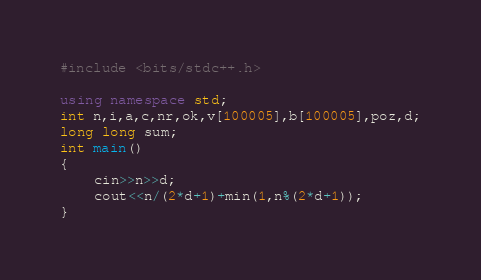Convert code to text. <code><loc_0><loc_0><loc_500><loc_500><_C++_>#include <bits/stdc++.h>

using namespace std;
int n,i,a,c,nr,ok,v[100005],b[100005],poz,d;
long long sum;
int main()
{
    cin>>n>>d;
    cout<<n/(2*d+1)+min(1,n%(2*d+1));
}
</code> 